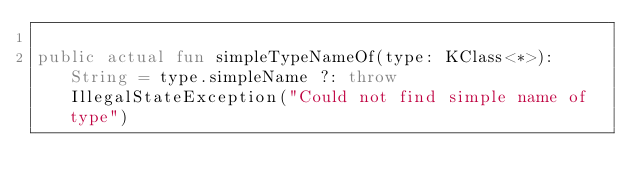Convert code to text. <code><loc_0><loc_0><loc_500><loc_500><_Kotlin_>
public actual fun simpleTypeNameOf(type: KClass<*>): String = type.simpleName ?: throw IllegalStateException("Could not find simple name of type")
</code> 